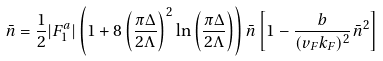Convert formula to latex. <formula><loc_0><loc_0><loc_500><loc_500>\bar { n } = \frac { 1 } { 2 } | F _ { 1 } ^ { a } | \left ( 1 + 8 \left ( \frac { \pi \Delta } { 2 \Lambda } \right ) ^ { 2 } \ln \left ( \frac { \pi \Delta } { 2 \Lambda } \right ) \right ) \bar { n } \left [ 1 - \frac { b } { ( v _ { F } k _ { F } ) ^ { 2 } } \bar { n } ^ { 2 } \right ]</formula> 